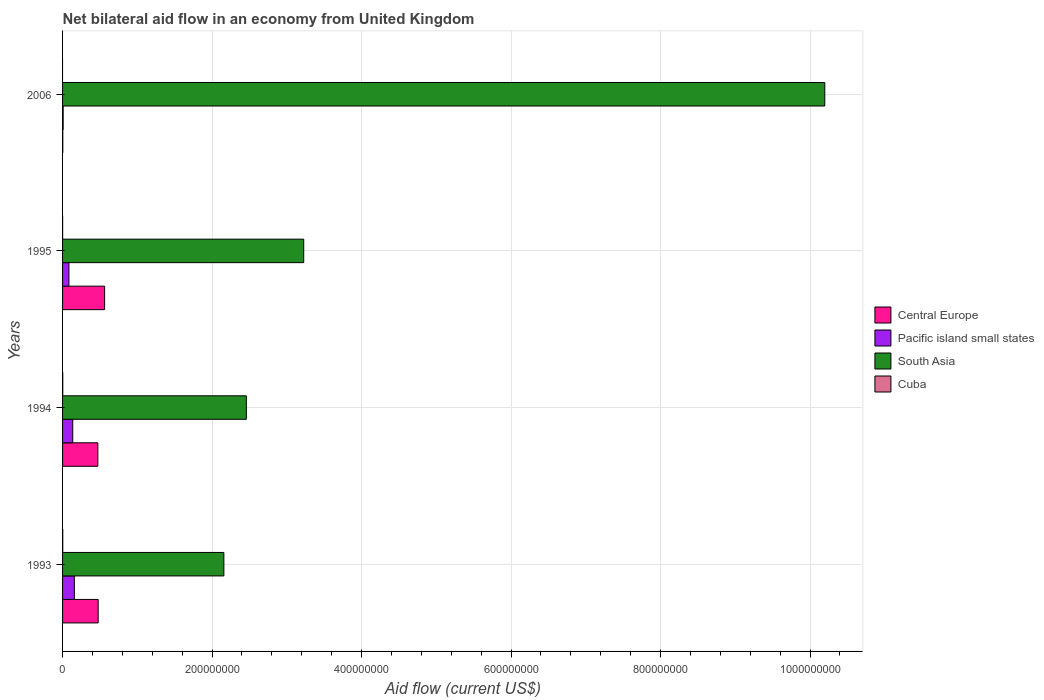How many different coloured bars are there?
Give a very brief answer. 4. Are the number of bars on each tick of the Y-axis equal?
Offer a terse response. No. What is the label of the 3rd group of bars from the top?
Your answer should be compact. 1994. In how many cases, is the number of bars for a given year not equal to the number of legend labels?
Your answer should be compact. 1. What is the net bilateral aid flow in Central Europe in 1993?
Keep it short and to the point. 4.77e+07. Across all years, what is the maximum net bilateral aid flow in South Asia?
Your response must be concise. 1.02e+09. In which year was the net bilateral aid flow in Central Europe maximum?
Provide a short and direct response. 1995. What is the total net bilateral aid flow in Pacific island small states in the graph?
Give a very brief answer. 3.87e+07. What is the difference between the net bilateral aid flow in Central Europe in 1994 and that in 2006?
Offer a very short reply. 4.69e+07. What is the difference between the net bilateral aid flow in Central Europe in 1993 and the net bilateral aid flow in Pacific island small states in 1995?
Provide a short and direct response. 3.91e+07. What is the average net bilateral aid flow in Cuba per year?
Provide a succinct answer. 1.48e+05. In the year 1995, what is the difference between the net bilateral aid flow in Central Europe and net bilateral aid flow in Pacific island small states?
Provide a short and direct response. 4.77e+07. What is the ratio of the net bilateral aid flow in Pacific island small states in 1993 to that in 2006?
Ensure brevity in your answer.  19.71. What is the difference between the highest and the second highest net bilateral aid flow in Cuba?
Keep it short and to the point. 3.00e+04. What is the difference between the highest and the lowest net bilateral aid flow in South Asia?
Keep it short and to the point. 8.04e+08. In how many years, is the net bilateral aid flow in Pacific island small states greater than the average net bilateral aid flow in Pacific island small states taken over all years?
Your answer should be very brief. 2. Is the sum of the net bilateral aid flow in Cuba in 1993 and 1995 greater than the maximum net bilateral aid flow in Central Europe across all years?
Your answer should be very brief. No. Is it the case that in every year, the sum of the net bilateral aid flow in South Asia and net bilateral aid flow in Pacific island small states is greater than the sum of net bilateral aid flow in Central Europe and net bilateral aid flow in Cuba?
Your response must be concise. Yes. Are the values on the major ticks of X-axis written in scientific E-notation?
Give a very brief answer. No. Does the graph contain any zero values?
Give a very brief answer. Yes. Where does the legend appear in the graph?
Your answer should be compact. Center right. How many legend labels are there?
Your response must be concise. 4. How are the legend labels stacked?
Ensure brevity in your answer.  Vertical. What is the title of the graph?
Offer a terse response. Net bilateral aid flow in an economy from United Kingdom. What is the label or title of the X-axis?
Your answer should be very brief. Aid flow (current US$). What is the Aid flow (current US$) in Central Europe in 1993?
Ensure brevity in your answer.  4.77e+07. What is the Aid flow (current US$) of Pacific island small states in 1993?
Provide a succinct answer. 1.58e+07. What is the Aid flow (current US$) in South Asia in 1993?
Give a very brief answer. 2.16e+08. What is the Aid flow (current US$) in Central Europe in 1994?
Offer a terse response. 4.72e+07. What is the Aid flow (current US$) of Pacific island small states in 1994?
Your answer should be very brief. 1.36e+07. What is the Aid flow (current US$) in South Asia in 1994?
Give a very brief answer. 2.46e+08. What is the Aid flow (current US$) in Cuba in 1994?
Your answer should be compact. 2.70e+05. What is the Aid flow (current US$) of Central Europe in 1995?
Ensure brevity in your answer.  5.63e+07. What is the Aid flow (current US$) of Pacific island small states in 1995?
Offer a terse response. 8.53e+06. What is the Aid flow (current US$) of South Asia in 1995?
Your answer should be compact. 3.23e+08. What is the Aid flow (current US$) of Cuba in 1995?
Give a very brief answer. 8.00e+04. What is the Aid flow (current US$) of Central Europe in 2006?
Keep it short and to the point. 3.10e+05. What is the Aid flow (current US$) of Pacific island small states in 2006?
Your answer should be very brief. 8.00e+05. What is the Aid flow (current US$) of South Asia in 2006?
Ensure brevity in your answer.  1.02e+09. Across all years, what is the maximum Aid flow (current US$) of Central Europe?
Offer a very short reply. 5.63e+07. Across all years, what is the maximum Aid flow (current US$) of Pacific island small states?
Provide a short and direct response. 1.58e+07. Across all years, what is the maximum Aid flow (current US$) in South Asia?
Make the answer very short. 1.02e+09. Across all years, what is the minimum Aid flow (current US$) of South Asia?
Provide a short and direct response. 2.16e+08. What is the total Aid flow (current US$) of Central Europe in the graph?
Ensure brevity in your answer.  1.51e+08. What is the total Aid flow (current US$) in Pacific island small states in the graph?
Your response must be concise. 3.87e+07. What is the total Aid flow (current US$) in South Asia in the graph?
Ensure brevity in your answer.  1.80e+09. What is the total Aid flow (current US$) in Cuba in the graph?
Your answer should be compact. 5.90e+05. What is the difference between the Aid flow (current US$) of Central Europe in 1993 and that in 1994?
Provide a short and direct response. 4.70e+05. What is the difference between the Aid flow (current US$) of Pacific island small states in 1993 and that in 1994?
Give a very brief answer. 2.14e+06. What is the difference between the Aid flow (current US$) in South Asia in 1993 and that in 1994?
Keep it short and to the point. -3.01e+07. What is the difference between the Aid flow (current US$) in Central Europe in 1993 and that in 1995?
Ensure brevity in your answer.  -8.60e+06. What is the difference between the Aid flow (current US$) in Pacific island small states in 1993 and that in 1995?
Provide a short and direct response. 7.24e+06. What is the difference between the Aid flow (current US$) of South Asia in 1993 and that in 1995?
Make the answer very short. -1.07e+08. What is the difference between the Aid flow (current US$) in Central Europe in 1993 and that in 2006?
Provide a short and direct response. 4.74e+07. What is the difference between the Aid flow (current US$) of Pacific island small states in 1993 and that in 2006?
Offer a very short reply. 1.50e+07. What is the difference between the Aid flow (current US$) in South Asia in 1993 and that in 2006?
Your answer should be compact. -8.04e+08. What is the difference between the Aid flow (current US$) in Central Europe in 1994 and that in 1995?
Ensure brevity in your answer.  -9.07e+06. What is the difference between the Aid flow (current US$) in Pacific island small states in 1994 and that in 1995?
Give a very brief answer. 5.10e+06. What is the difference between the Aid flow (current US$) in South Asia in 1994 and that in 1995?
Your answer should be compact. -7.68e+07. What is the difference between the Aid flow (current US$) of Cuba in 1994 and that in 1995?
Offer a very short reply. 1.90e+05. What is the difference between the Aid flow (current US$) in Central Europe in 1994 and that in 2006?
Your answer should be very brief. 4.69e+07. What is the difference between the Aid flow (current US$) of Pacific island small states in 1994 and that in 2006?
Make the answer very short. 1.28e+07. What is the difference between the Aid flow (current US$) of South Asia in 1994 and that in 2006?
Your answer should be compact. -7.74e+08. What is the difference between the Aid flow (current US$) in Central Europe in 1995 and that in 2006?
Make the answer very short. 5.60e+07. What is the difference between the Aid flow (current US$) in Pacific island small states in 1995 and that in 2006?
Make the answer very short. 7.73e+06. What is the difference between the Aid flow (current US$) in South Asia in 1995 and that in 2006?
Your answer should be very brief. -6.97e+08. What is the difference between the Aid flow (current US$) of Central Europe in 1993 and the Aid flow (current US$) of Pacific island small states in 1994?
Keep it short and to the point. 3.40e+07. What is the difference between the Aid flow (current US$) in Central Europe in 1993 and the Aid flow (current US$) in South Asia in 1994?
Ensure brevity in your answer.  -1.98e+08. What is the difference between the Aid flow (current US$) of Central Europe in 1993 and the Aid flow (current US$) of Cuba in 1994?
Provide a succinct answer. 4.74e+07. What is the difference between the Aid flow (current US$) of Pacific island small states in 1993 and the Aid flow (current US$) of South Asia in 1994?
Your response must be concise. -2.30e+08. What is the difference between the Aid flow (current US$) in Pacific island small states in 1993 and the Aid flow (current US$) in Cuba in 1994?
Your answer should be compact. 1.55e+07. What is the difference between the Aid flow (current US$) of South Asia in 1993 and the Aid flow (current US$) of Cuba in 1994?
Your response must be concise. 2.16e+08. What is the difference between the Aid flow (current US$) of Central Europe in 1993 and the Aid flow (current US$) of Pacific island small states in 1995?
Offer a very short reply. 3.91e+07. What is the difference between the Aid flow (current US$) of Central Europe in 1993 and the Aid flow (current US$) of South Asia in 1995?
Your answer should be compact. -2.75e+08. What is the difference between the Aid flow (current US$) in Central Europe in 1993 and the Aid flow (current US$) in Cuba in 1995?
Provide a succinct answer. 4.76e+07. What is the difference between the Aid flow (current US$) in Pacific island small states in 1993 and the Aid flow (current US$) in South Asia in 1995?
Your response must be concise. -3.07e+08. What is the difference between the Aid flow (current US$) of Pacific island small states in 1993 and the Aid flow (current US$) of Cuba in 1995?
Give a very brief answer. 1.57e+07. What is the difference between the Aid flow (current US$) in South Asia in 1993 and the Aid flow (current US$) in Cuba in 1995?
Offer a very short reply. 2.16e+08. What is the difference between the Aid flow (current US$) in Central Europe in 1993 and the Aid flow (current US$) in Pacific island small states in 2006?
Ensure brevity in your answer.  4.69e+07. What is the difference between the Aid flow (current US$) in Central Europe in 1993 and the Aid flow (current US$) in South Asia in 2006?
Make the answer very short. -9.72e+08. What is the difference between the Aid flow (current US$) of Pacific island small states in 1993 and the Aid flow (current US$) of South Asia in 2006?
Your answer should be very brief. -1.00e+09. What is the difference between the Aid flow (current US$) in Central Europe in 1994 and the Aid flow (current US$) in Pacific island small states in 1995?
Ensure brevity in your answer.  3.87e+07. What is the difference between the Aid flow (current US$) of Central Europe in 1994 and the Aid flow (current US$) of South Asia in 1995?
Keep it short and to the point. -2.75e+08. What is the difference between the Aid flow (current US$) in Central Europe in 1994 and the Aid flow (current US$) in Cuba in 1995?
Your answer should be compact. 4.71e+07. What is the difference between the Aid flow (current US$) in Pacific island small states in 1994 and the Aid flow (current US$) in South Asia in 1995?
Offer a very short reply. -3.09e+08. What is the difference between the Aid flow (current US$) in Pacific island small states in 1994 and the Aid flow (current US$) in Cuba in 1995?
Offer a very short reply. 1.36e+07. What is the difference between the Aid flow (current US$) of South Asia in 1994 and the Aid flow (current US$) of Cuba in 1995?
Provide a short and direct response. 2.46e+08. What is the difference between the Aid flow (current US$) in Central Europe in 1994 and the Aid flow (current US$) in Pacific island small states in 2006?
Offer a very short reply. 4.64e+07. What is the difference between the Aid flow (current US$) in Central Europe in 1994 and the Aid flow (current US$) in South Asia in 2006?
Make the answer very short. -9.73e+08. What is the difference between the Aid flow (current US$) of Pacific island small states in 1994 and the Aid flow (current US$) of South Asia in 2006?
Make the answer very short. -1.01e+09. What is the difference between the Aid flow (current US$) of Central Europe in 1995 and the Aid flow (current US$) of Pacific island small states in 2006?
Provide a short and direct response. 5.55e+07. What is the difference between the Aid flow (current US$) in Central Europe in 1995 and the Aid flow (current US$) in South Asia in 2006?
Offer a very short reply. -9.63e+08. What is the difference between the Aid flow (current US$) of Pacific island small states in 1995 and the Aid flow (current US$) of South Asia in 2006?
Your answer should be very brief. -1.01e+09. What is the average Aid flow (current US$) of Central Europe per year?
Your response must be concise. 3.79e+07. What is the average Aid flow (current US$) in Pacific island small states per year?
Ensure brevity in your answer.  9.68e+06. What is the average Aid flow (current US$) of South Asia per year?
Ensure brevity in your answer.  4.51e+08. What is the average Aid flow (current US$) in Cuba per year?
Your answer should be compact. 1.48e+05. In the year 1993, what is the difference between the Aid flow (current US$) in Central Europe and Aid flow (current US$) in Pacific island small states?
Your answer should be very brief. 3.19e+07. In the year 1993, what is the difference between the Aid flow (current US$) in Central Europe and Aid flow (current US$) in South Asia?
Offer a terse response. -1.68e+08. In the year 1993, what is the difference between the Aid flow (current US$) in Central Europe and Aid flow (current US$) in Cuba?
Your answer should be compact. 4.74e+07. In the year 1993, what is the difference between the Aid flow (current US$) in Pacific island small states and Aid flow (current US$) in South Asia?
Keep it short and to the point. -2.00e+08. In the year 1993, what is the difference between the Aid flow (current US$) of Pacific island small states and Aid flow (current US$) of Cuba?
Your answer should be very brief. 1.55e+07. In the year 1993, what is the difference between the Aid flow (current US$) in South Asia and Aid flow (current US$) in Cuba?
Offer a terse response. 2.16e+08. In the year 1994, what is the difference between the Aid flow (current US$) in Central Europe and Aid flow (current US$) in Pacific island small states?
Offer a terse response. 3.36e+07. In the year 1994, what is the difference between the Aid flow (current US$) in Central Europe and Aid flow (current US$) in South Asia?
Offer a very short reply. -1.99e+08. In the year 1994, what is the difference between the Aid flow (current US$) in Central Europe and Aid flow (current US$) in Cuba?
Offer a very short reply. 4.69e+07. In the year 1994, what is the difference between the Aid flow (current US$) of Pacific island small states and Aid flow (current US$) of South Asia?
Make the answer very short. -2.32e+08. In the year 1994, what is the difference between the Aid flow (current US$) in Pacific island small states and Aid flow (current US$) in Cuba?
Offer a very short reply. 1.34e+07. In the year 1994, what is the difference between the Aid flow (current US$) in South Asia and Aid flow (current US$) in Cuba?
Your response must be concise. 2.46e+08. In the year 1995, what is the difference between the Aid flow (current US$) in Central Europe and Aid flow (current US$) in Pacific island small states?
Your answer should be very brief. 4.77e+07. In the year 1995, what is the difference between the Aid flow (current US$) of Central Europe and Aid flow (current US$) of South Asia?
Provide a succinct answer. -2.66e+08. In the year 1995, what is the difference between the Aid flow (current US$) in Central Europe and Aid flow (current US$) in Cuba?
Your response must be concise. 5.62e+07. In the year 1995, what is the difference between the Aid flow (current US$) of Pacific island small states and Aid flow (current US$) of South Asia?
Your answer should be compact. -3.14e+08. In the year 1995, what is the difference between the Aid flow (current US$) of Pacific island small states and Aid flow (current US$) of Cuba?
Offer a very short reply. 8.45e+06. In the year 1995, what is the difference between the Aid flow (current US$) of South Asia and Aid flow (current US$) of Cuba?
Provide a succinct answer. 3.23e+08. In the year 2006, what is the difference between the Aid flow (current US$) in Central Europe and Aid flow (current US$) in Pacific island small states?
Your response must be concise. -4.90e+05. In the year 2006, what is the difference between the Aid flow (current US$) of Central Europe and Aid flow (current US$) of South Asia?
Your answer should be compact. -1.02e+09. In the year 2006, what is the difference between the Aid flow (current US$) in Pacific island small states and Aid flow (current US$) in South Asia?
Your answer should be compact. -1.02e+09. What is the ratio of the Aid flow (current US$) in Pacific island small states in 1993 to that in 1994?
Your answer should be very brief. 1.16. What is the ratio of the Aid flow (current US$) in South Asia in 1993 to that in 1994?
Your answer should be very brief. 0.88. What is the ratio of the Aid flow (current US$) of Central Europe in 1993 to that in 1995?
Make the answer very short. 0.85. What is the ratio of the Aid flow (current US$) of Pacific island small states in 1993 to that in 1995?
Your answer should be very brief. 1.85. What is the ratio of the Aid flow (current US$) of South Asia in 1993 to that in 1995?
Keep it short and to the point. 0.67. What is the ratio of the Aid flow (current US$) of Cuba in 1993 to that in 1995?
Your response must be concise. 3. What is the ratio of the Aid flow (current US$) in Central Europe in 1993 to that in 2006?
Keep it short and to the point. 153.74. What is the ratio of the Aid flow (current US$) in Pacific island small states in 1993 to that in 2006?
Keep it short and to the point. 19.71. What is the ratio of the Aid flow (current US$) of South Asia in 1993 to that in 2006?
Ensure brevity in your answer.  0.21. What is the ratio of the Aid flow (current US$) in Central Europe in 1994 to that in 1995?
Ensure brevity in your answer.  0.84. What is the ratio of the Aid flow (current US$) of Pacific island small states in 1994 to that in 1995?
Provide a short and direct response. 1.6. What is the ratio of the Aid flow (current US$) in South Asia in 1994 to that in 1995?
Keep it short and to the point. 0.76. What is the ratio of the Aid flow (current US$) of Cuba in 1994 to that in 1995?
Your answer should be compact. 3.38. What is the ratio of the Aid flow (current US$) in Central Europe in 1994 to that in 2006?
Make the answer very short. 152.23. What is the ratio of the Aid flow (current US$) of Pacific island small states in 1994 to that in 2006?
Your response must be concise. 17.04. What is the ratio of the Aid flow (current US$) in South Asia in 1994 to that in 2006?
Ensure brevity in your answer.  0.24. What is the ratio of the Aid flow (current US$) of Central Europe in 1995 to that in 2006?
Your answer should be compact. 181.48. What is the ratio of the Aid flow (current US$) of Pacific island small states in 1995 to that in 2006?
Offer a terse response. 10.66. What is the ratio of the Aid flow (current US$) of South Asia in 1995 to that in 2006?
Keep it short and to the point. 0.32. What is the difference between the highest and the second highest Aid flow (current US$) in Central Europe?
Offer a terse response. 8.60e+06. What is the difference between the highest and the second highest Aid flow (current US$) in Pacific island small states?
Offer a terse response. 2.14e+06. What is the difference between the highest and the second highest Aid flow (current US$) in South Asia?
Give a very brief answer. 6.97e+08. What is the difference between the highest and the second highest Aid flow (current US$) in Cuba?
Your answer should be very brief. 3.00e+04. What is the difference between the highest and the lowest Aid flow (current US$) of Central Europe?
Make the answer very short. 5.60e+07. What is the difference between the highest and the lowest Aid flow (current US$) in Pacific island small states?
Your answer should be compact. 1.50e+07. What is the difference between the highest and the lowest Aid flow (current US$) of South Asia?
Keep it short and to the point. 8.04e+08. 